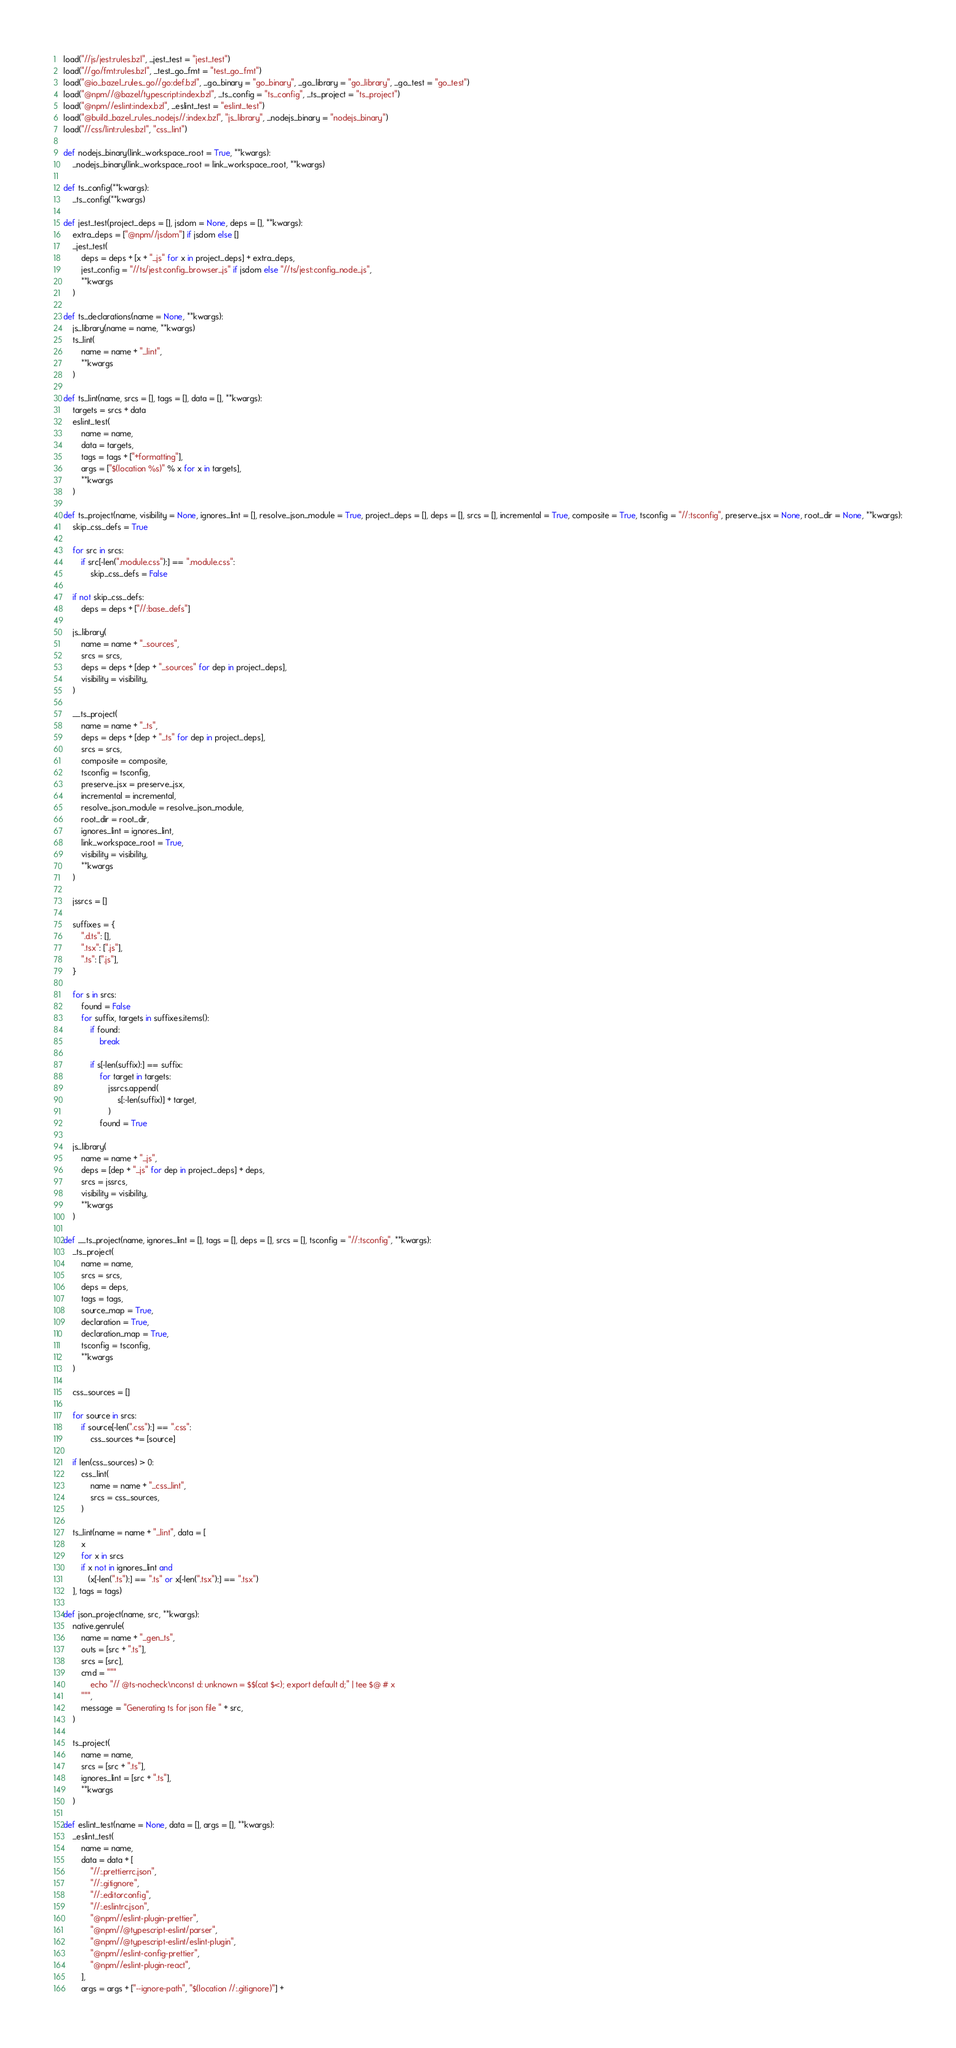<code> <loc_0><loc_0><loc_500><loc_500><_Python_>load("//js/jest:rules.bzl", _jest_test = "jest_test")
load("//go/fmt:rules.bzl", _test_go_fmt = "test_go_fmt")
load("@io_bazel_rules_go//go:def.bzl", _go_binary = "go_binary", _go_library = "go_library", _go_test = "go_test")
load("@npm//@bazel/typescript:index.bzl", _ts_config = "ts_config", _ts_project = "ts_project")
load("@npm//eslint:index.bzl", _eslint_test = "eslint_test")
load("@build_bazel_rules_nodejs//:index.bzl", "js_library", _nodejs_binary = "nodejs_binary")
load("//css/lint:rules.bzl", "css_lint")

def nodejs_binary(link_workspace_root = True, **kwargs):
    _nodejs_binary(link_workspace_root = link_workspace_root, **kwargs)

def ts_config(**kwargs):
    _ts_config(**kwargs)

def jest_test(project_deps = [], jsdom = None, deps = [], **kwargs):
    extra_deps = ["@npm//jsdom"] if jsdom else []
    _jest_test(
        deps = deps + [x + "_js" for x in project_deps] + extra_deps,
        jest_config = "//ts/jest:config_browser_js" if jsdom else "//ts/jest:config_node_js",
        **kwargs
    )

def ts_declarations(name = None, **kwargs):
    js_library(name = name, **kwargs)
    ts_lint(
        name = name + "_lint",
        **kwargs
    )

def ts_lint(name, srcs = [], tags = [], data = [], **kwargs):
    targets = srcs + data
    eslint_test(
        name = name,
        data = targets,
        tags = tags + ["+formatting"],
        args = ["$(location %s)" % x for x in targets],
        **kwargs
    )

def ts_project(name, visibility = None, ignores_lint = [], resolve_json_module = True, project_deps = [], deps = [], srcs = [], incremental = True, composite = True, tsconfig = "//:tsconfig", preserve_jsx = None, root_dir = None, **kwargs):
    skip_css_defs = True

    for src in srcs:
        if src[-len(".module.css"):] == ".module.css":
            skip_css_defs = False

    if not skip_css_defs:
        deps = deps + ["//:base_defs"]

    js_library(
        name = name + "_sources",
        srcs = srcs,
        deps = deps + [dep + "_sources" for dep in project_deps],
        visibility = visibility,
    )

    __ts_project(
        name = name + "_ts",
        deps = deps + [dep + "_ts" for dep in project_deps],
        srcs = srcs,
        composite = composite,
        tsconfig = tsconfig,
        preserve_jsx = preserve_jsx,
        incremental = incremental,
        resolve_json_module = resolve_json_module,
        root_dir = root_dir,
        ignores_lint = ignores_lint,
        link_workspace_root = True,
        visibility = visibility,
        **kwargs
    )

    jssrcs = []

    suffixes = {
        ".d.ts": [],
        ".tsx": [".js"],
        ".ts": [".js"],
    }

    for s in srcs:
        found = False
        for suffix, targets in suffixes.items():
            if found:
                break

            if s[-len(suffix):] == suffix:
                for target in targets:
                    jssrcs.append(
                        s[:-len(suffix)] + target,
                    )
                found = True

    js_library(
        name = name + "_js",
        deps = [dep + "_js" for dep in project_deps] + deps,
        srcs = jssrcs,
        visibility = visibility,
        **kwargs
    )

def __ts_project(name, ignores_lint = [], tags = [], deps = [], srcs = [], tsconfig = "//:tsconfig", **kwargs):
    _ts_project(
        name = name,
        srcs = srcs,
        deps = deps,
        tags = tags,
        source_map = True,
        declaration = True,
        declaration_map = True,
        tsconfig = tsconfig,
        **kwargs
    )

    css_sources = []

    for source in srcs:
        if source[-len(".css"):] == ".css":
            css_sources += [source]

    if len(css_sources) > 0:
        css_lint(
            name = name + "_css_lint",
            srcs = css_sources,
        )

    ts_lint(name = name + "_lint", data = [
        x
        for x in srcs
        if x not in ignores_lint and
           (x[-len(".ts"):] == ".ts" or x[-len(".tsx"):] == ".tsx")
    ], tags = tags)

def json_project(name, src, **kwargs):
    native.genrule(
        name = name + "_gen_ts",
        outs = [src + ".ts"],
        srcs = [src],
        cmd = """
            echo "// @ts-nocheck\nconst d: unknown = $$(cat $<); export default d;" | tee $@ # x
        """,
        message = "Generating ts for json file " + src,
    )

    ts_project(
        name = name,
        srcs = [src + ".ts"],
        ignores_lint = [src + ".ts"],
        **kwargs
    )

def eslint_test(name = None, data = [], args = [], **kwargs):
    _eslint_test(
        name = name,
        data = data + [
            "//:.prettierrc.json",
            "//:.gitignore",
            "//:.editorconfig",
            "//:.eslintrc.json",
            "@npm//eslint-plugin-prettier",
            "@npm//@typescript-eslint/parser",
            "@npm//@typescript-eslint/eslint-plugin",
            "@npm//eslint-config-prettier",
            "@npm//eslint-plugin-react",
        ],
        args = args + ["--ignore-path", "$(location //:.gitignore)"] +</code> 